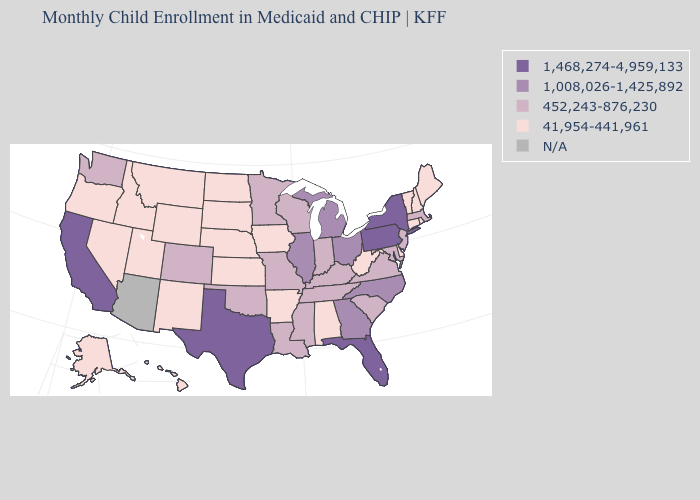What is the highest value in the USA?
Write a very short answer. 1,468,274-4,959,133. Does Indiana have the lowest value in the MidWest?
Write a very short answer. No. Among the states that border Texas , which have the lowest value?
Write a very short answer. Arkansas, New Mexico. Name the states that have a value in the range 452,243-876,230?
Write a very short answer. Colorado, Indiana, Kentucky, Louisiana, Maryland, Massachusetts, Minnesota, Mississippi, Missouri, New Jersey, Oklahoma, South Carolina, Tennessee, Virginia, Washington, Wisconsin. Name the states that have a value in the range N/A?
Be succinct. Arizona. Which states hav the highest value in the Northeast?
Short answer required. New York, Pennsylvania. What is the highest value in the MidWest ?
Answer briefly. 1,008,026-1,425,892. Among the states that border Wyoming , does Colorado have the highest value?
Short answer required. Yes. Name the states that have a value in the range 1,468,274-4,959,133?
Concise answer only. California, Florida, New York, Pennsylvania, Texas. Which states have the highest value in the USA?
Answer briefly. California, Florida, New York, Pennsylvania, Texas. Among the states that border New Jersey , does Pennsylvania have the highest value?
Be succinct. Yes. Name the states that have a value in the range 1,008,026-1,425,892?
Quick response, please. Georgia, Illinois, Michigan, North Carolina, Ohio. What is the value of Indiana?
Answer briefly. 452,243-876,230. 